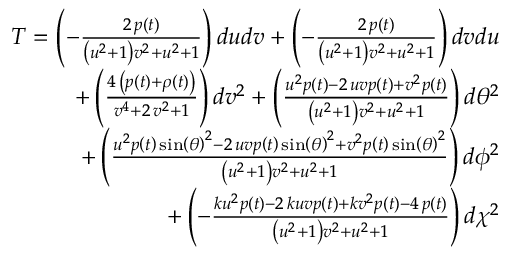Convert formula to latex. <formula><loc_0><loc_0><loc_500><loc_500>\begin{array} { r } { T = \left ( - \frac { 2 \, p \left ( t \right ) } { { \left ( u ^ { 2 } + 1 \right ) } v ^ { 2 } + u ^ { 2 } + 1 } \right ) d u d v + \left ( - \frac { 2 \, p \left ( t \right ) } { { \left ( u ^ { 2 } + 1 \right ) } v ^ { 2 } + u ^ { 2 } + 1 } \right ) d v d u } \\ { + \left ( \frac { 4 \, { \left ( p \left ( t \right ) + \rho \left ( t \right ) \right ) } } { v ^ { 4 } + 2 \, v ^ { 2 } + 1 } \right ) d v ^ { 2 } + \left ( \frac { u ^ { 2 } p \left ( t \right ) - 2 \, u v p \left ( t \right ) + v ^ { 2 } p \left ( t \right ) } { { \left ( u ^ { 2 } + 1 \right ) } v ^ { 2 } + u ^ { 2 } + 1 } \right ) d \theta ^ { 2 } } \\ { + \left ( \frac { u ^ { 2 } p \left ( t \right ) \sin \left ( { \theta } \right ) ^ { 2 } - 2 \, u v p \left ( t \right ) \sin \left ( { \theta } \right ) ^ { 2 } + v ^ { 2 } p \left ( t \right ) \sin \left ( { \theta } \right ) ^ { 2 } } { { \left ( u ^ { 2 } + 1 \right ) } v ^ { 2 } + u ^ { 2 } + 1 } \right ) d \phi ^ { 2 } } \\ { + \left ( - \frac { k u ^ { 2 } p \left ( t \right ) - 2 \, k u v p \left ( t \right ) + k v ^ { 2 } p \left ( t \right ) - 4 \, p \left ( t \right ) } { { \left ( u ^ { 2 } + 1 \right ) } v ^ { 2 } + u ^ { 2 } + 1 } \right ) d \chi ^ { 2 } } \end{array}</formula> 